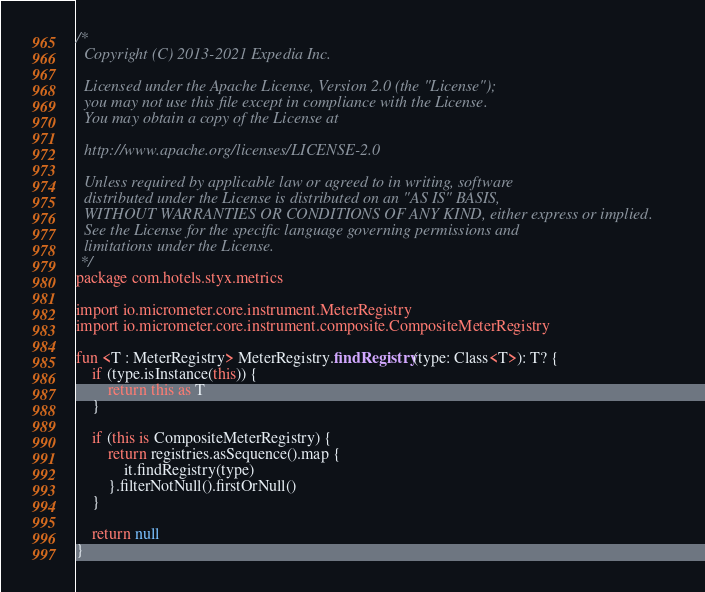<code> <loc_0><loc_0><loc_500><loc_500><_Kotlin_>/*
  Copyright (C) 2013-2021 Expedia Inc.

  Licensed under the Apache License, Version 2.0 (the "License");
  you may not use this file except in compliance with the License.
  You may obtain a copy of the License at

  http://www.apache.org/licenses/LICENSE-2.0

  Unless required by applicable law or agreed to in writing, software
  distributed under the License is distributed on an "AS IS" BASIS,
  WITHOUT WARRANTIES OR CONDITIONS OF ANY KIND, either express or implied.
  See the License for the specific language governing permissions and
  limitations under the License.
 */
package com.hotels.styx.metrics

import io.micrometer.core.instrument.MeterRegistry
import io.micrometer.core.instrument.composite.CompositeMeterRegistry

fun <T : MeterRegistry> MeterRegistry.findRegistry(type: Class<T>): T? {
    if (type.isInstance(this)) {
        return this as T
    }

    if (this is CompositeMeterRegistry) {
        return registries.asSequence().map {
            it.findRegistry(type)
        }.filterNotNull().firstOrNull()
    }

    return null
}
</code> 